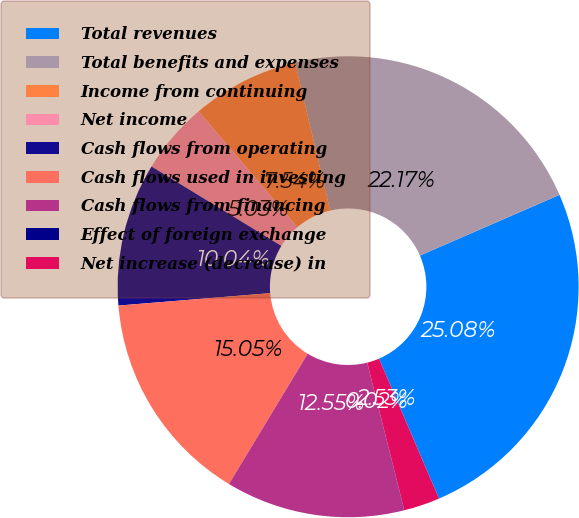Convert chart. <chart><loc_0><loc_0><loc_500><loc_500><pie_chart><fcel>Total revenues<fcel>Total benefits and expenses<fcel>Income from continuing<fcel>Net income<fcel>Cash flows from operating<fcel>Cash flows used in investing<fcel>Cash flows from financing<fcel>Effect of foreign exchange<fcel>Net increase (decrease) in<nl><fcel>25.08%<fcel>22.17%<fcel>7.54%<fcel>5.03%<fcel>10.04%<fcel>15.05%<fcel>12.55%<fcel>0.02%<fcel>2.53%<nl></chart> 